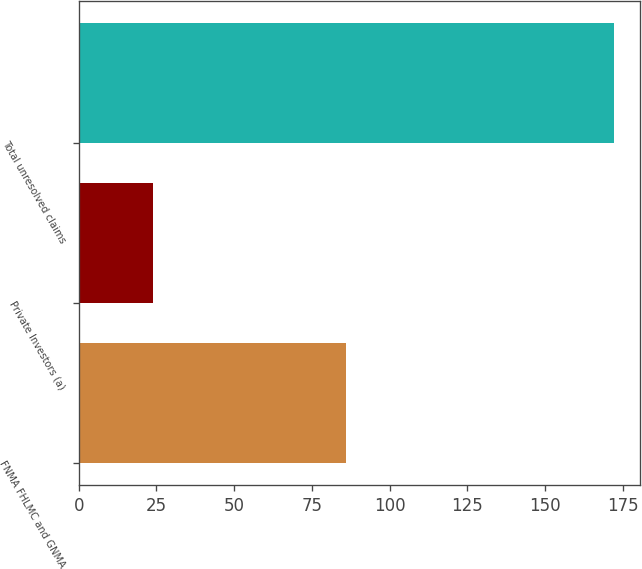Convert chart. <chart><loc_0><loc_0><loc_500><loc_500><bar_chart><fcel>FNMA FHLMC and GNMA<fcel>Private Investors (a)<fcel>Total unresolved claims<nl><fcel>86<fcel>24<fcel>172<nl></chart> 